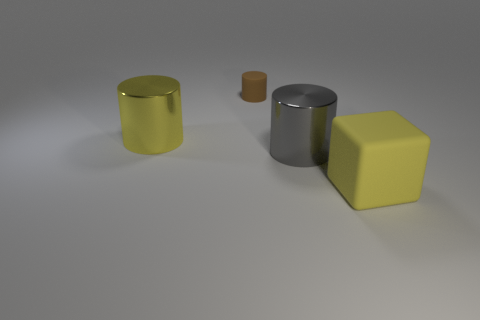Add 4 big purple rubber objects. How many objects exist? 8 Subtract all cylinders. How many objects are left? 1 Subtract all tiny brown matte objects. Subtract all big cyan metal blocks. How many objects are left? 3 Add 2 large gray metal things. How many large gray metal things are left? 3 Add 4 purple matte things. How many purple matte things exist? 4 Subtract 1 yellow cubes. How many objects are left? 3 